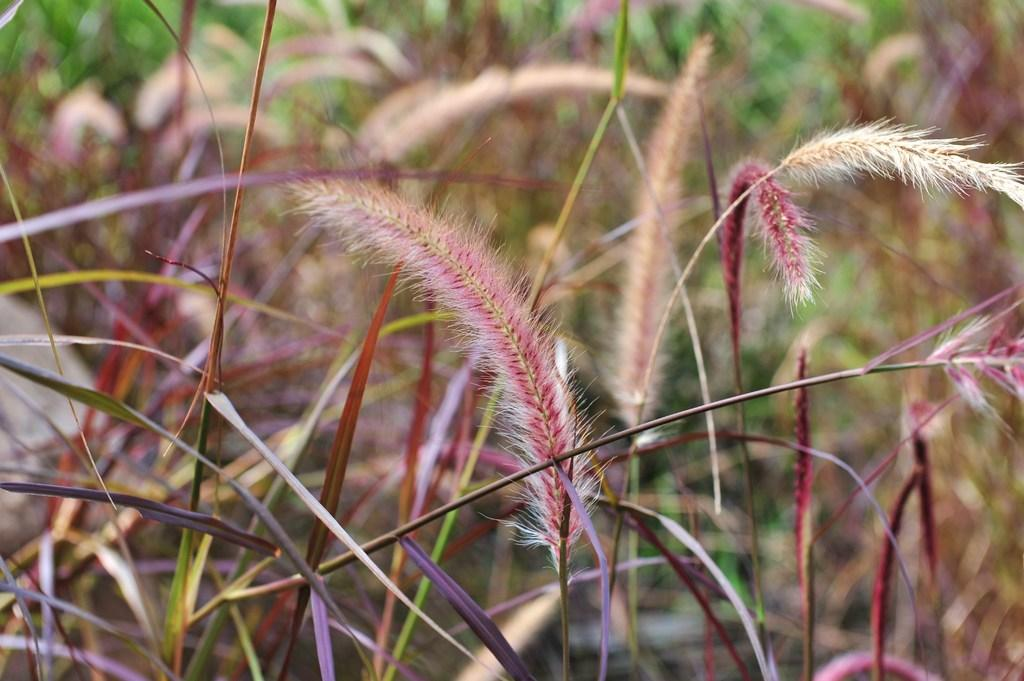What type of living organisms can be seen in the image? Plants can be seen in the image. Can you describe the background of the image? The background of the image is blurred. What type of mouth can be seen on the plants in the image? There are no mouths present on the plants in the image, as plants do not have mouths. 